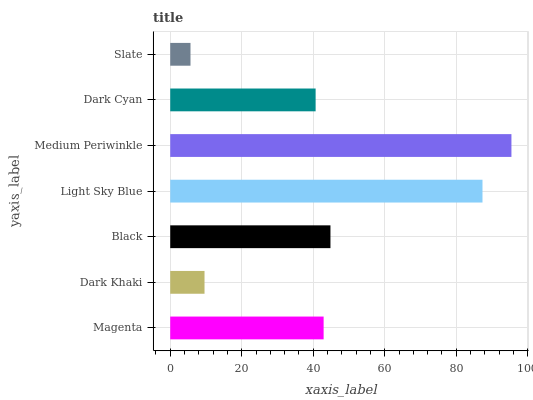Is Slate the minimum?
Answer yes or no. Yes. Is Medium Periwinkle the maximum?
Answer yes or no. Yes. Is Dark Khaki the minimum?
Answer yes or no. No. Is Dark Khaki the maximum?
Answer yes or no. No. Is Magenta greater than Dark Khaki?
Answer yes or no. Yes. Is Dark Khaki less than Magenta?
Answer yes or no. Yes. Is Dark Khaki greater than Magenta?
Answer yes or no. No. Is Magenta less than Dark Khaki?
Answer yes or no. No. Is Magenta the high median?
Answer yes or no. Yes. Is Magenta the low median?
Answer yes or no. Yes. Is Light Sky Blue the high median?
Answer yes or no. No. Is Slate the low median?
Answer yes or no. No. 